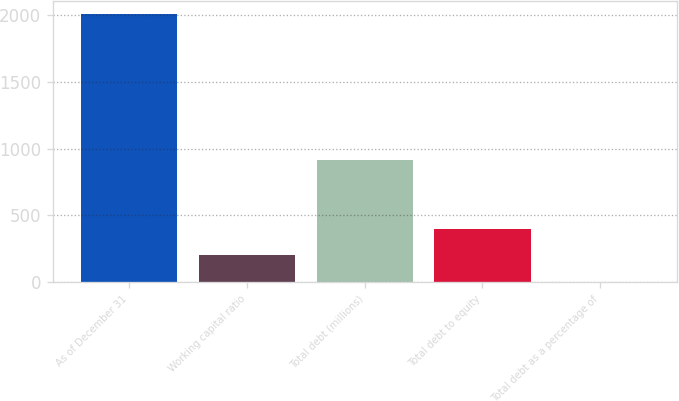<chart> <loc_0><loc_0><loc_500><loc_500><bar_chart><fcel>As of December 31<fcel>Working capital ratio<fcel>Total debt (millions)<fcel>Total debt to equity<fcel>Total debt as a percentage of<nl><fcel>2007<fcel>201.36<fcel>913.1<fcel>401.99<fcel>0.73<nl></chart> 